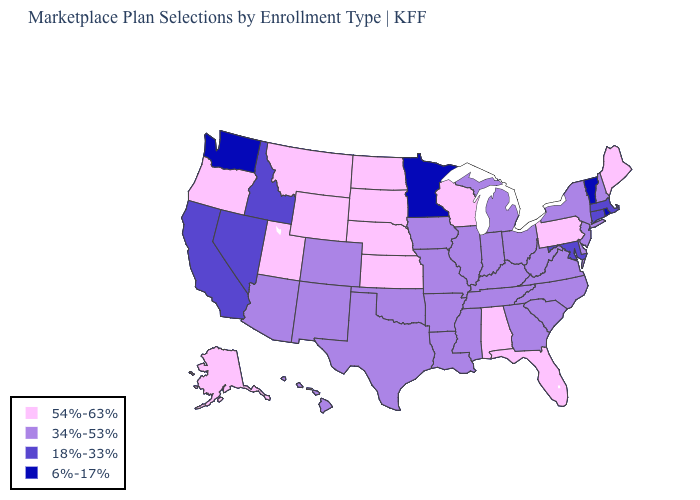Name the states that have a value in the range 34%-53%?
Answer briefly. Arizona, Arkansas, Colorado, Delaware, Georgia, Hawaii, Illinois, Indiana, Iowa, Kentucky, Louisiana, Michigan, Mississippi, Missouri, New Hampshire, New Jersey, New Mexico, New York, North Carolina, Ohio, Oklahoma, South Carolina, Tennessee, Texas, Virginia, West Virginia. What is the value of New Mexico?
Give a very brief answer. 34%-53%. What is the value of Connecticut?
Keep it brief. 18%-33%. Which states hav the highest value in the South?
Be succinct. Alabama, Florida. Among the states that border Montana , does North Dakota have the highest value?
Short answer required. Yes. What is the highest value in the USA?
Keep it brief. 54%-63%. What is the lowest value in the West?
Write a very short answer. 6%-17%. Name the states that have a value in the range 54%-63%?
Concise answer only. Alabama, Alaska, Florida, Kansas, Maine, Montana, Nebraska, North Dakota, Oregon, Pennsylvania, South Dakota, Utah, Wisconsin, Wyoming. Does Missouri have the lowest value in the USA?
Keep it brief. No. What is the value of Tennessee?
Be succinct. 34%-53%. Which states have the highest value in the USA?
Short answer required. Alabama, Alaska, Florida, Kansas, Maine, Montana, Nebraska, North Dakota, Oregon, Pennsylvania, South Dakota, Utah, Wisconsin, Wyoming. Which states have the highest value in the USA?
Quick response, please. Alabama, Alaska, Florida, Kansas, Maine, Montana, Nebraska, North Dakota, Oregon, Pennsylvania, South Dakota, Utah, Wisconsin, Wyoming. Does Maine have the lowest value in the USA?
Short answer required. No. Name the states that have a value in the range 54%-63%?
Short answer required. Alabama, Alaska, Florida, Kansas, Maine, Montana, Nebraska, North Dakota, Oregon, Pennsylvania, South Dakota, Utah, Wisconsin, Wyoming. Name the states that have a value in the range 54%-63%?
Keep it brief. Alabama, Alaska, Florida, Kansas, Maine, Montana, Nebraska, North Dakota, Oregon, Pennsylvania, South Dakota, Utah, Wisconsin, Wyoming. 